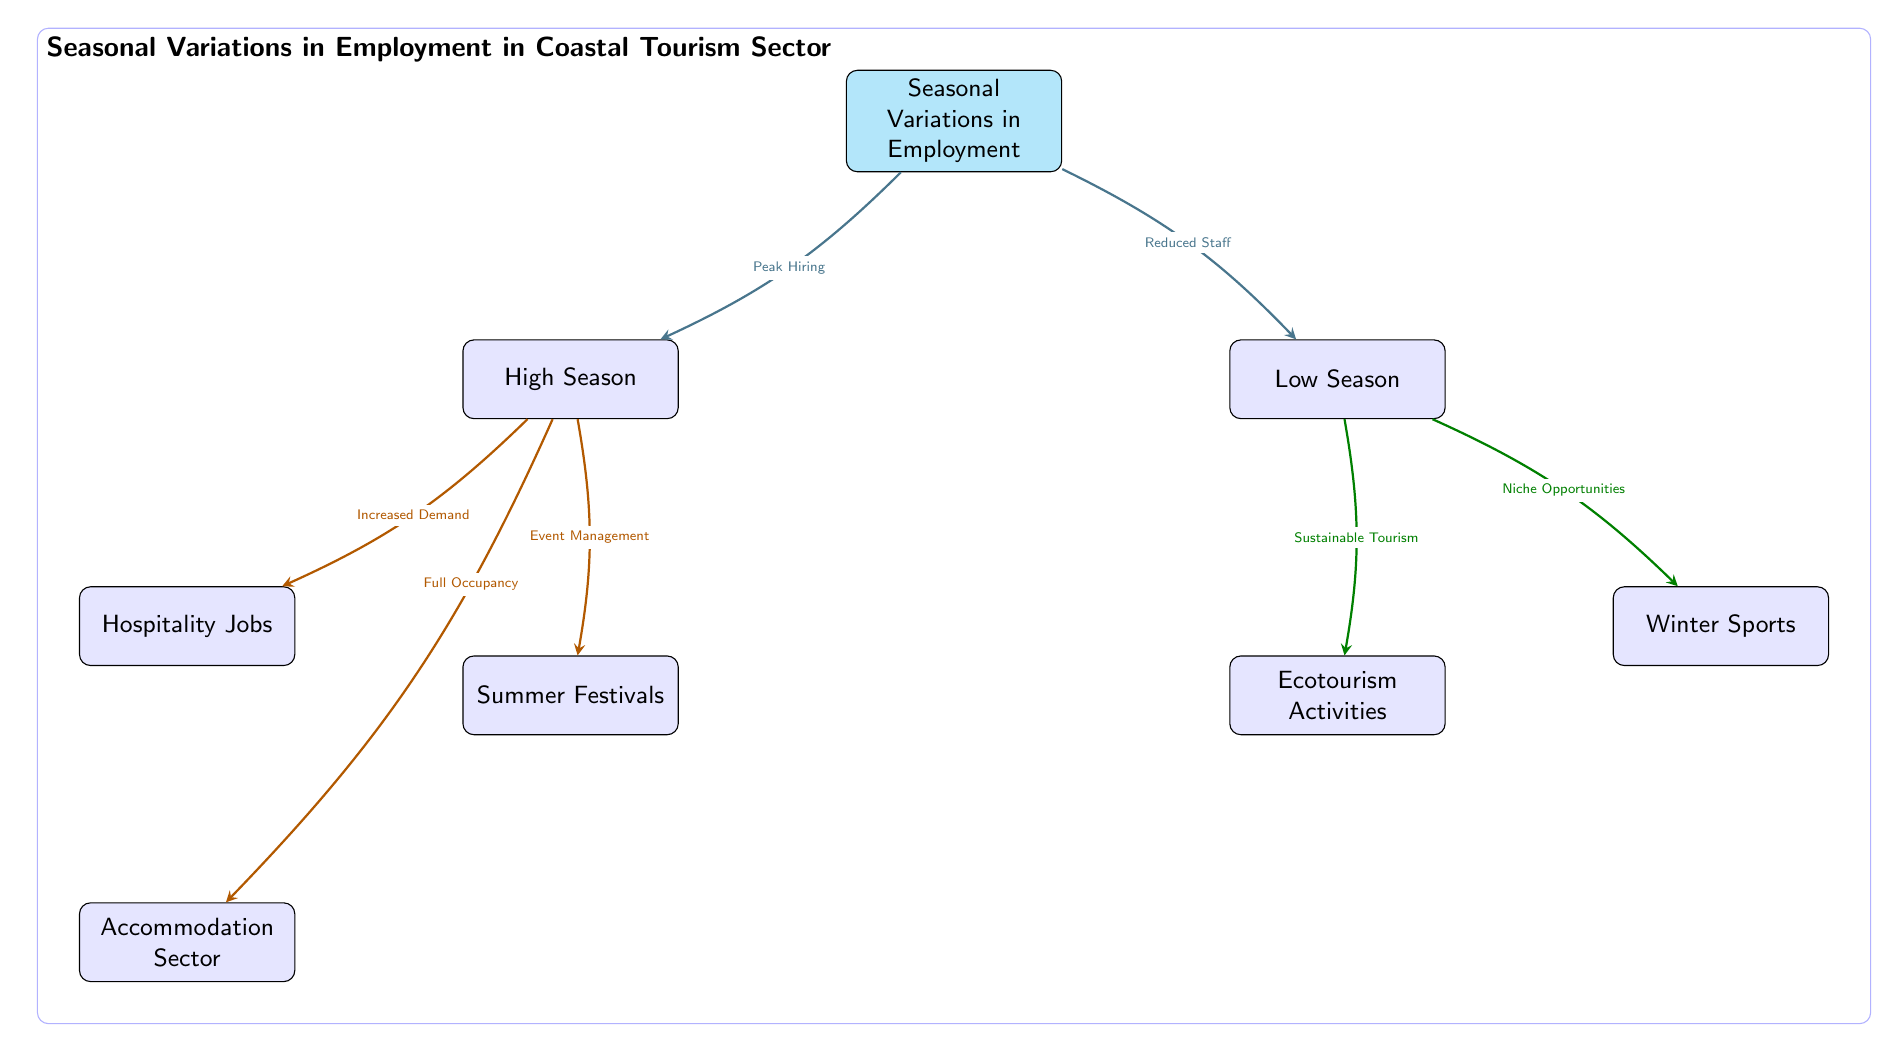What is the main focus of the diagram? The diagram focuses on "Seasonal Variations in Employment" as indicated in the title at the top of the diagram.
Answer: Seasonal Variations in Employment How many main seasonal periods are shown in the diagram? The diagram indicates two main seasonal periods: "High Season" and "Low Season," which are listed directly below the main focus.
Answer: 2 What type of jobs are primarily associated with the High Season? The diagram connects "High Season" to "Hospitality Jobs," indicating that these jobs are primarily associated with this period.
Answer: Hospitality Jobs What relationship exists between High Season and Summer Festivals? The diagram depicts a direct relationship from "High Season" to "Summer Festivals," labeled "Event Management," suggesting that the two are linked through event management activities.
Answer: Event Management What opportunity is presented in the Low Season for winter activities? The diagram describes "Niche Opportunities" that relate to "Winter Sports," indicating that there are specific opportunities in the Low Season for winter-related tourism.
Answer: Niche Opportunities What is the connection between Low Season and Sustainable Tourism? The diagram indicates that "Low Season" leads to "Sustainable Tourism" with the label "Sustainable Tourism," suggesting that during this time, there are opportunities for ecotourism.
Answer: Sustainable Tourism How does the High Season affect the Accommodation Sector? The diagram shows that "High Season" leads to "Accommodation Sector" with "Full Occupancy," indicating that demand during this period results in full bookings for accommodations.
Answer: Full Occupancy What are the three major components under High Season in the diagram? The diagram includes "Hospitality Jobs," "Summer Festivals," and "Accommodation Sector" as major components related to the High Season, indicating a diverse set of job opportunities during peak tourism time.
Answer: Hospitality Jobs, Summer Festivals, Accommodation Sector What type of tourism is associated with the Low Season according to the diagram? The diagram connects "Low Season" to "Ecotourism Activities," indicating that this type of tourism is particularly promoted during the Low Season.
Answer: Ecotourism Activities 